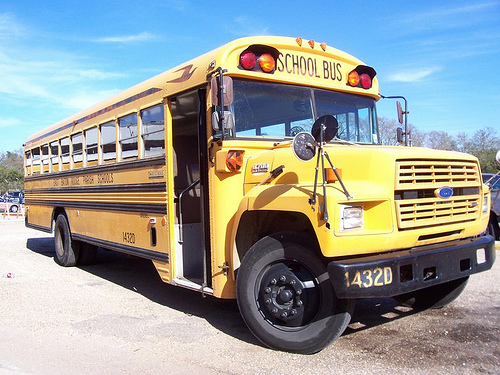Is the license plate number clear and identifiable? The license plate number is clearly visible and legible in the image. It reads '432D'. 